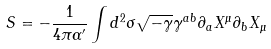<formula> <loc_0><loc_0><loc_500><loc_500>S = - \frac { 1 } { 4 \pi \alpha ^ { \prime } } \int d ^ { 2 } \sigma \sqrt { - \gamma } \gamma ^ { a b } \partial _ { a } X ^ { \mu } \partial _ { b } X _ { \mu }</formula> 